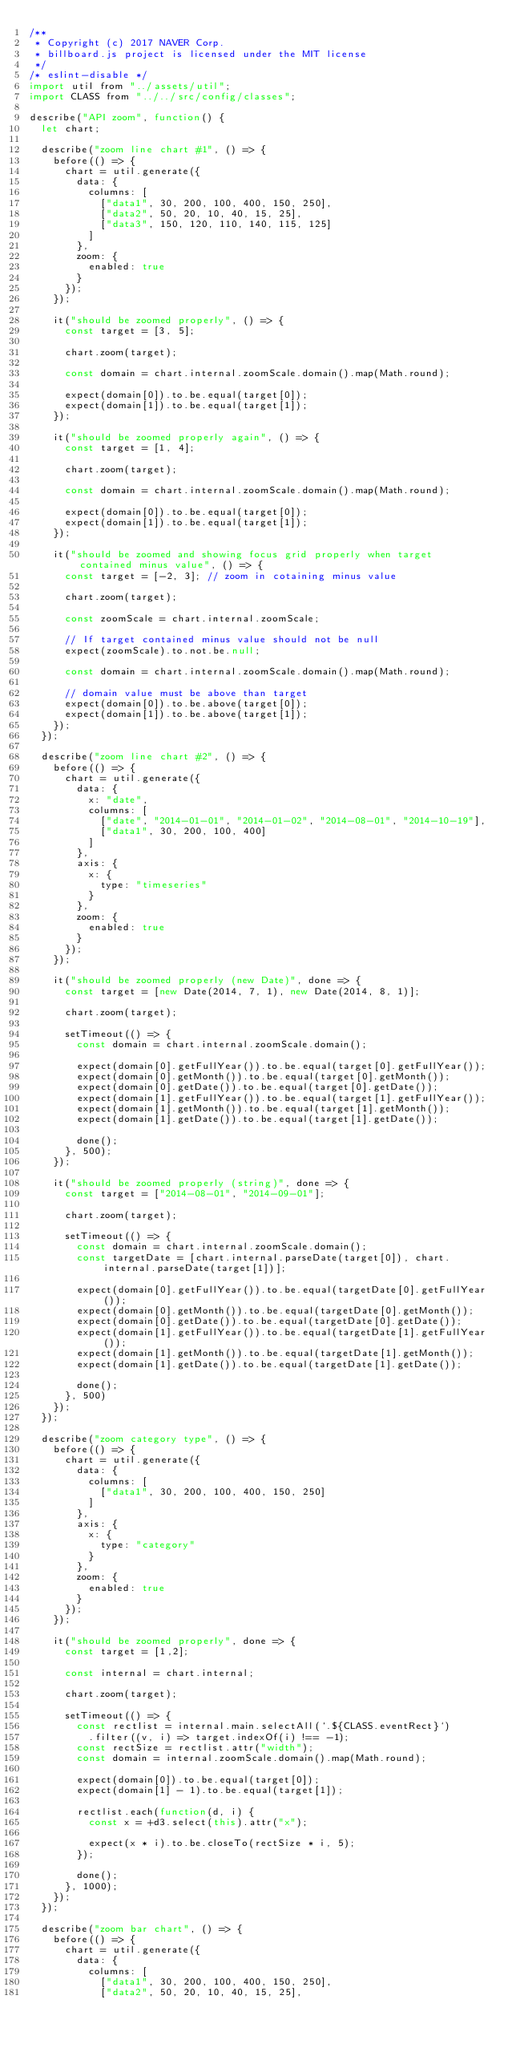Convert code to text. <code><loc_0><loc_0><loc_500><loc_500><_JavaScript_>/**
 * Copyright (c) 2017 NAVER Corp.
 * billboard.js project is licensed under the MIT license
 */
/* eslint-disable */
import util from "../assets/util";
import CLASS from "../../src/config/classes";

describe("API zoom", function() {
	let chart;

	describe("zoom line chart #1", () => {
		before(() => {
			chart = util.generate({
				data: {
					columns: [
						["data1", 30, 200, 100, 400, 150, 250],
						["data2", 50, 20, 10, 40, 15, 25],
						["data3", 150, 120, 110, 140, 115, 125]
					]
				},
				zoom: {
					enabled: true
				}
			});
		});

		it("should be zoomed properly", () => {
			const target = [3, 5];

			chart.zoom(target);

			const domain = chart.internal.zoomScale.domain().map(Math.round);

			expect(domain[0]).to.be.equal(target[0]);
			expect(domain[1]).to.be.equal(target[1]);
		});

		it("should be zoomed properly again", () => {
			const target = [1, 4];

			chart.zoom(target);

			const domain = chart.internal.zoomScale.domain().map(Math.round);

			expect(domain[0]).to.be.equal(target[0]);
			expect(domain[1]).to.be.equal(target[1]);
		});

		it("should be zoomed and showing focus grid properly when target contained minus value", () => {
			const target = [-2, 3]; // zoom in cotaining minus value

			chart.zoom(target);

			const zoomScale = chart.internal.zoomScale;

			// If target contained minus value should not be null
			expect(zoomScale).to.not.be.null;

			const domain = chart.internal.zoomScale.domain().map(Math.round);

			// domain value must be above than target
			expect(domain[0]).to.be.above(target[0]);
			expect(domain[1]).to.be.above(target[1]);
		});
	});

	describe("zoom line chart #2", () => {
		before(() => {
			chart = util.generate({
				data: {
					x: "date",
					columns: [
						["date", "2014-01-01", "2014-01-02", "2014-08-01", "2014-10-19"],
						["data1", 30, 200, 100, 400]
					]
				},
				axis: {
					x: {
						type: "timeseries"
					}
				},
				zoom: {
					enabled: true
				}
			});
		});

		it("should be zoomed properly (new Date)", done => {
			const target = [new Date(2014, 7, 1), new Date(2014, 8, 1)];

			chart.zoom(target);

			setTimeout(() => {
				const domain = chart.internal.zoomScale.domain();

				expect(domain[0].getFullYear()).to.be.equal(target[0].getFullYear());
				expect(domain[0].getMonth()).to.be.equal(target[0].getMonth());
				expect(domain[0].getDate()).to.be.equal(target[0].getDate());
				expect(domain[1].getFullYear()).to.be.equal(target[1].getFullYear());
				expect(domain[1].getMonth()).to.be.equal(target[1].getMonth());
				expect(domain[1].getDate()).to.be.equal(target[1].getDate());

				done();
			}, 500);
		});

		it("should be zoomed properly (string)", done => {
			const target = ["2014-08-01", "2014-09-01"];

			chart.zoom(target);

			setTimeout(() => {
				const domain = chart.internal.zoomScale.domain();
				const targetDate = [chart.internal.parseDate(target[0]), chart.internal.parseDate(target[1])];

				expect(domain[0].getFullYear()).to.be.equal(targetDate[0].getFullYear());
				expect(domain[0].getMonth()).to.be.equal(targetDate[0].getMonth());
				expect(domain[0].getDate()).to.be.equal(targetDate[0].getDate());
				expect(domain[1].getFullYear()).to.be.equal(targetDate[1].getFullYear());
				expect(domain[1].getMonth()).to.be.equal(targetDate[1].getMonth());
				expect(domain[1].getDate()).to.be.equal(targetDate[1].getDate());

				done();
			}, 500)
		});
	});

	describe("zoom category type", () => {
		before(() => {
			chart = util.generate({
				data: {
					columns: [
						["data1", 30, 200, 100, 400, 150, 250]
					]
				},
				axis: {
					x: {
						type: "category"
					}
				},
				zoom: {
					enabled: true
				}
			});
		});

		it("should be zoomed properly", done => {
			const target = [1,2];

			const internal = chart.internal;

			chart.zoom(target);

			setTimeout(() => {
				const rectlist = internal.main.selectAll(`.${CLASS.eventRect}`)
					.filter((v, i) => target.indexOf(i) !== -1);
				const rectSize = rectlist.attr("width");
				const domain = internal.zoomScale.domain().map(Math.round);

				expect(domain[0]).to.be.equal(target[0]);
				expect(domain[1] - 1).to.be.equal(target[1]);

				rectlist.each(function(d, i) {
					const x = +d3.select(this).attr("x");

					expect(x * i).to.be.closeTo(rectSize * i, 5);
				});

				done();
			}, 1000);
		});
	});

	describe("zoom bar chart", () => {
		before(() => {
			chart = util.generate({
				data: {
					columns: [
						["data1", 30, 200, 100, 400, 150, 250],
						["data2", 50, 20, 10, 40, 15, 25],</code> 